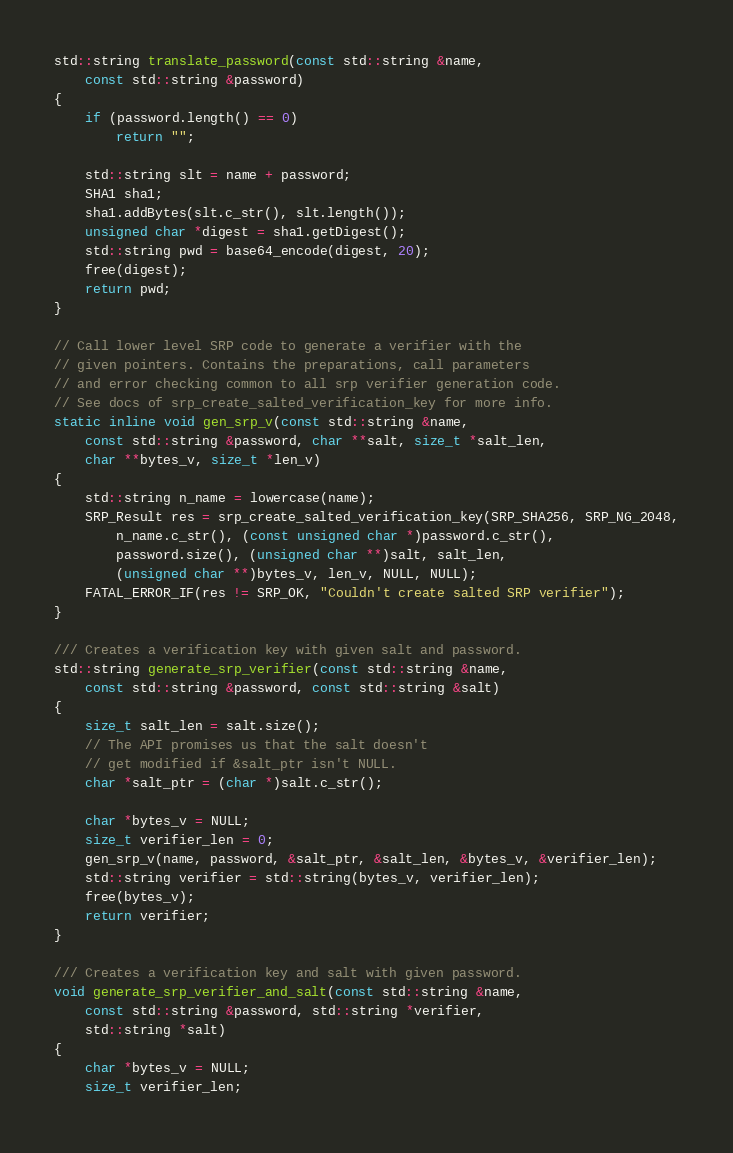<code> <loc_0><loc_0><loc_500><loc_500><_C++_>std::string translate_password(const std::string &name,
	const std::string &password)
{
	if (password.length() == 0)
		return "";

	std::string slt = name + password;
	SHA1 sha1;
	sha1.addBytes(slt.c_str(), slt.length());
	unsigned char *digest = sha1.getDigest();
	std::string pwd = base64_encode(digest, 20);
	free(digest);
	return pwd;
}

// Call lower level SRP code to generate a verifier with the
// given pointers. Contains the preparations, call parameters
// and error checking common to all srp verifier generation code.
// See docs of srp_create_salted_verification_key for more info.
static inline void gen_srp_v(const std::string &name,
	const std::string &password, char **salt, size_t *salt_len,
	char **bytes_v, size_t *len_v)
{
	std::string n_name = lowercase(name);
	SRP_Result res = srp_create_salted_verification_key(SRP_SHA256, SRP_NG_2048,
		n_name.c_str(), (const unsigned char *)password.c_str(),
		password.size(), (unsigned char **)salt, salt_len,
		(unsigned char **)bytes_v, len_v, NULL, NULL);
	FATAL_ERROR_IF(res != SRP_OK, "Couldn't create salted SRP verifier");
}

/// Creates a verification key with given salt and password.
std::string generate_srp_verifier(const std::string &name,
	const std::string &password, const std::string &salt)
{
	size_t salt_len = salt.size();
	// The API promises us that the salt doesn't
	// get modified if &salt_ptr isn't NULL.
	char *salt_ptr = (char *)salt.c_str();

	char *bytes_v = NULL;
	size_t verifier_len = 0;
	gen_srp_v(name, password, &salt_ptr, &salt_len, &bytes_v, &verifier_len);
	std::string verifier = std::string(bytes_v, verifier_len);
	free(bytes_v);
	return verifier;
}

/// Creates a verification key and salt with given password.
void generate_srp_verifier_and_salt(const std::string &name,
	const std::string &password, std::string *verifier,
	std::string *salt)
{
	char *bytes_v = NULL;
	size_t verifier_len;</code> 